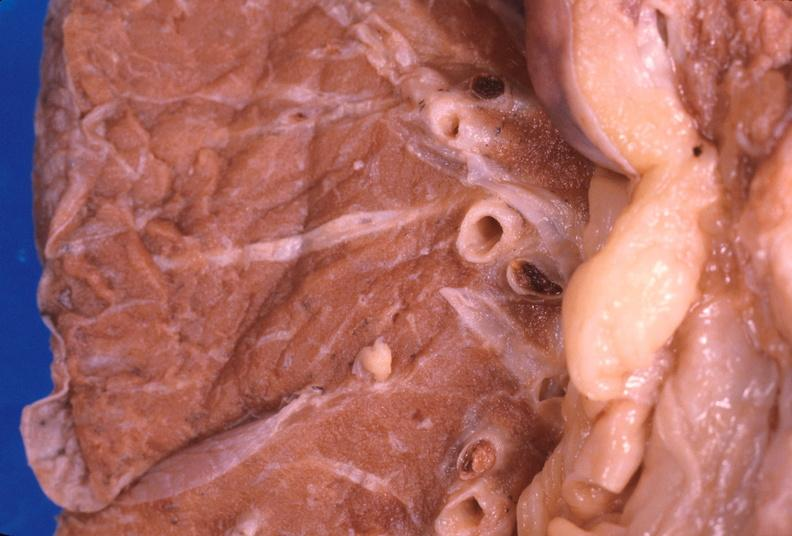what does this image show?
Answer the question using a single word or phrase. Thromboembolus from leg veins in pulmonary artery 